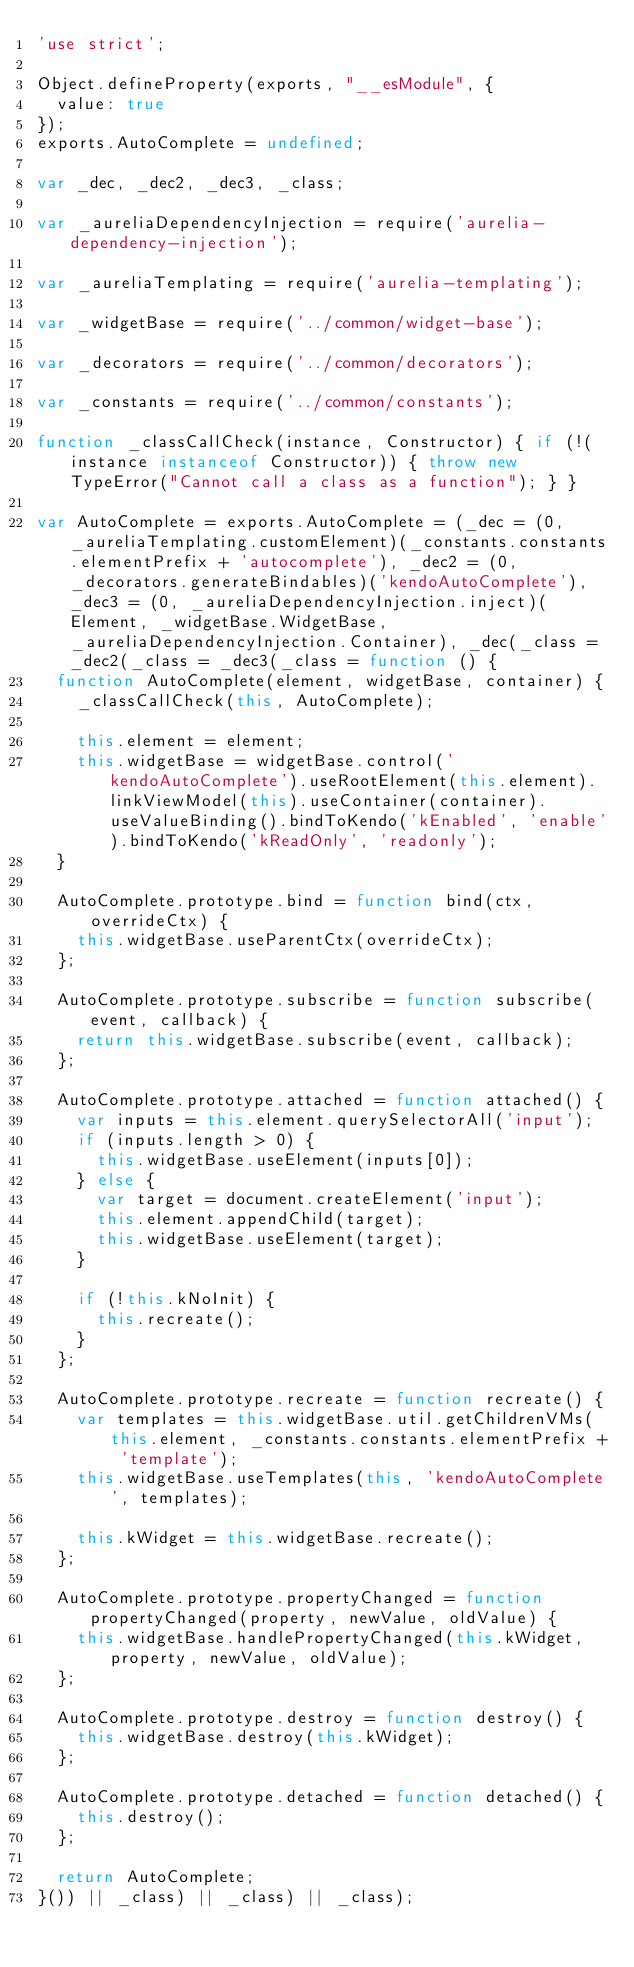<code> <loc_0><loc_0><loc_500><loc_500><_JavaScript_>'use strict';

Object.defineProperty(exports, "__esModule", {
  value: true
});
exports.AutoComplete = undefined;

var _dec, _dec2, _dec3, _class;

var _aureliaDependencyInjection = require('aurelia-dependency-injection');

var _aureliaTemplating = require('aurelia-templating');

var _widgetBase = require('../common/widget-base');

var _decorators = require('../common/decorators');

var _constants = require('../common/constants');

function _classCallCheck(instance, Constructor) { if (!(instance instanceof Constructor)) { throw new TypeError("Cannot call a class as a function"); } }

var AutoComplete = exports.AutoComplete = (_dec = (0, _aureliaTemplating.customElement)(_constants.constants.elementPrefix + 'autocomplete'), _dec2 = (0, _decorators.generateBindables)('kendoAutoComplete'), _dec3 = (0, _aureliaDependencyInjection.inject)(Element, _widgetBase.WidgetBase, _aureliaDependencyInjection.Container), _dec(_class = _dec2(_class = _dec3(_class = function () {
  function AutoComplete(element, widgetBase, container) {
    _classCallCheck(this, AutoComplete);

    this.element = element;
    this.widgetBase = widgetBase.control('kendoAutoComplete').useRootElement(this.element).linkViewModel(this).useContainer(container).useValueBinding().bindToKendo('kEnabled', 'enable').bindToKendo('kReadOnly', 'readonly');
  }

  AutoComplete.prototype.bind = function bind(ctx, overrideCtx) {
    this.widgetBase.useParentCtx(overrideCtx);
  };

  AutoComplete.prototype.subscribe = function subscribe(event, callback) {
    return this.widgetBase.subscribe(event, callback);
  };

  AutoComplete.prototype.attached = function attached() {
    var inputs = this.element.querySelectorAll('input');
    if (inputs.length > 0) {
      this.widgetBase.useElement(inputs[0]);
    } else {
      var target = document.createElement('input');
      this.element.appendChild(target);
      this.widgetBase.useElement(target);
    }

    if (!this.kNoInit) {
      this.recreate();
    }
  };

  AutoComplete.prototype.recreate = function recreate() {
    var templates = this.widgetBase.util.getChildrenVMs(this.element, _constants.constants.elementPrefix + 'template');
    this.widgetBase.useTemplates(this, 'kendoAutoComplete', templates);

    this.kWidget = this.widgetBase.recreate();
  };

  AutoComplete.prototype.propertyChanged = function propertyChanged(property, newValue, oldValue) {
    this.widgetBase.handlePropertyChanged(this.kWidget, property, newValue, oldValue);
  };

  AutoComplete.prototype.destroy = function destroy() {
    this.widgetBase.destroy(this.kWidget);
  };

  AutoComplete.prototype.detached = function detached() {
    this.destroy();
  };

  return AutoComplete;
}()) || _class) || _class) || _class);</code> 